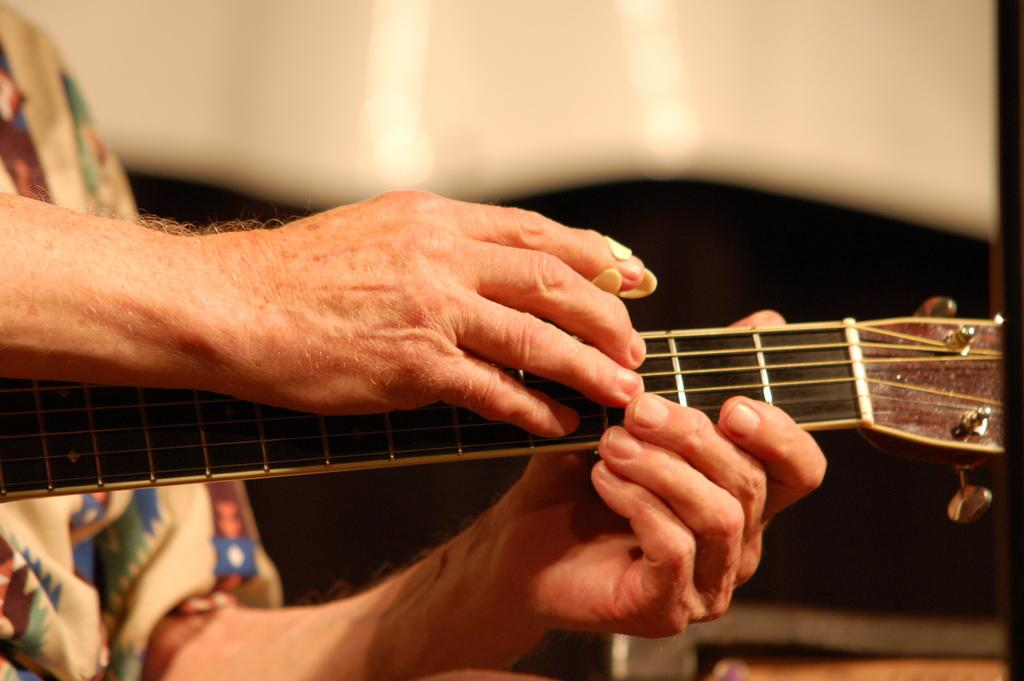What is the man in the image doing? The man is playing music. What instrument is the man holding in the image? The man is holding a guitar. Can you describe the man's activity in more detail? The man is playing the guitar, which suggests he is creating music. What type of curtain can be seen in the image? There is no curtain present in the image. Is there a fight happening in the image? There is no fight depicted in the image; the man is playing music. 